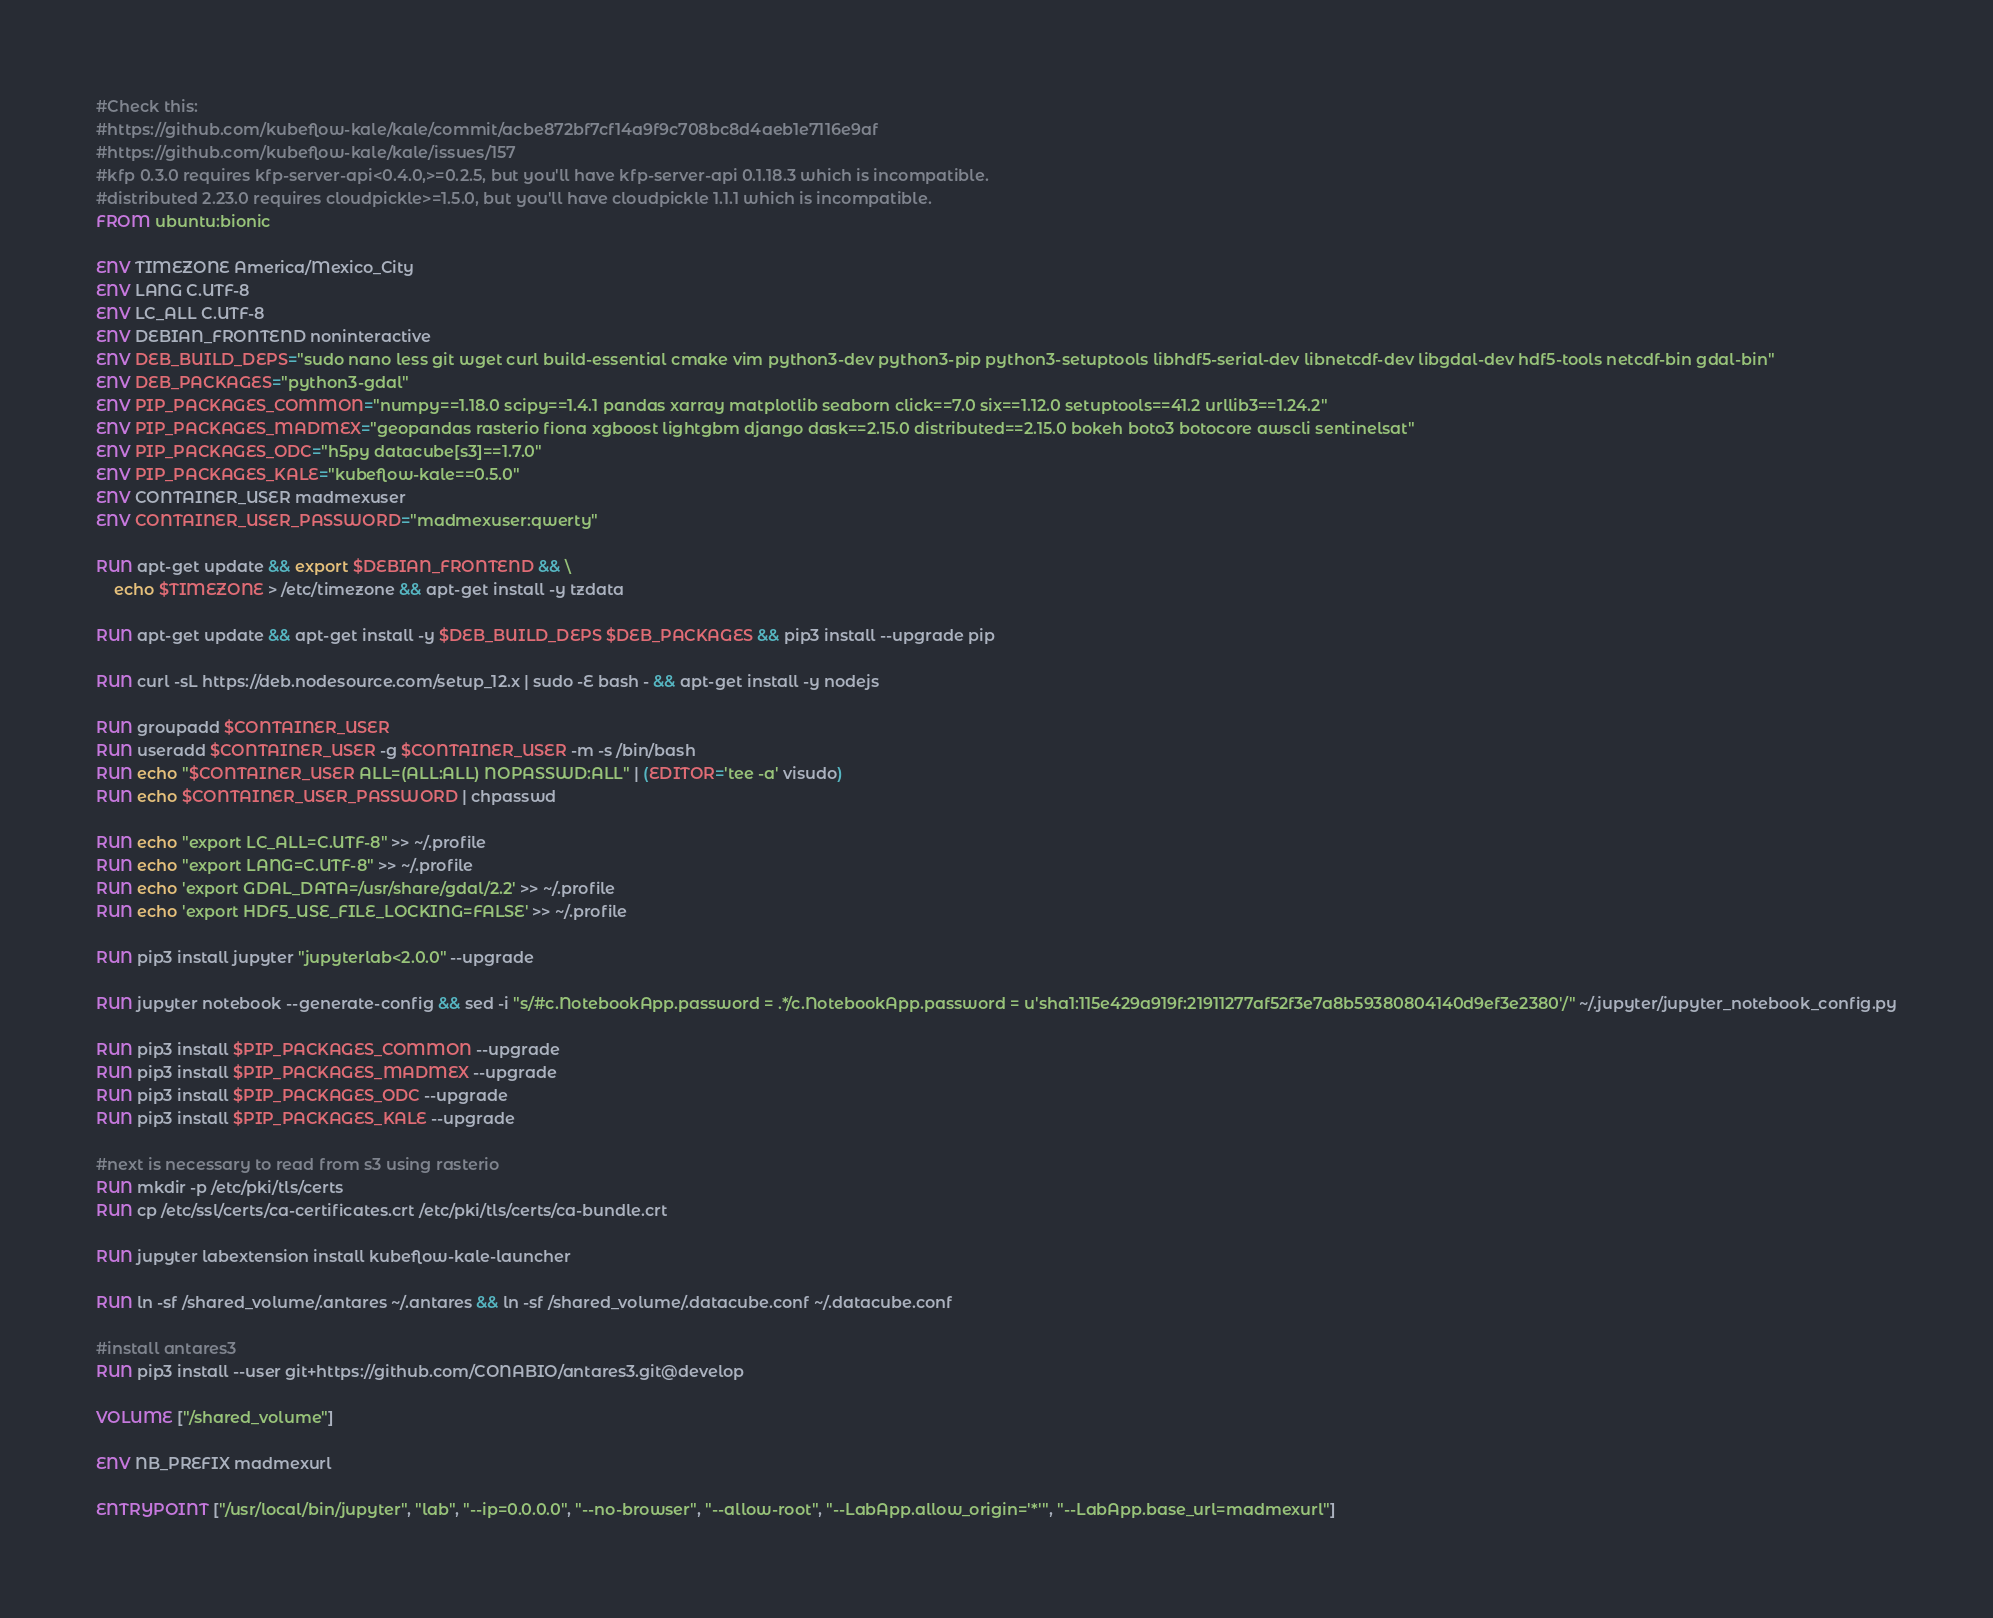Convert code to text. <code><loc_0><loc_0><loc_500><loc_500><_Dockerfile_>#Check this:
#https://github.com/kubeflow-kale/kale/commit/acbe872bf7cf14a9f9c708bc8d4aeb1e7116e9af
#https://github.com/kubeflow-kale/kale/issues/157
#kfp 0.3.0 requires kfp-server-api<0.4.0,>=0.2.5, but you'll have kfp-server-api 0.1.18.3 which is incompatible.
#distributed 2.23.0 requires cloudpickle>=1.5.0, but you'll have cloudpickle 1.1.1 which is incompatible.
FROM ubuntu:bionic

ENV TIMEZONE America/Mexico_City
ENV LANG C.UTF-8
ENV LC_ALL C.UTF-8
ENV DEBIAN_FRONTEND noninteractive 
ENV DEB_BUILD_DEPS="sudo nano less git wget curl build-essential cmake vim python3-dev python3-pip python3-setuptools libhdf5-serial-dev libnetcdf-dev libgdal-dev hdf5-tools netcdf-bin gdal-bin"
ENV DEB_PACKAGES="python3-gdal"
ENV PIP_PACKAGES_COMMON="numpy==1.18.0 scipy==1.4.1 pandas xarray matplotlib seaborn click==7.0 six==1.12.0 setuptools==41.2 urllib3==1.24.2"
ENV PIP_PACKAGES_MADMEX="geopandas rasterio fiona xgboost lightgbm django dask==2.15.0 distributed==2.15.0 bokeh boto3 botocore awscli sentinelsat"
ENV PIP_PACKAGES_ODC="h5py datacube[s3]==1.7.0"
ENV PIP_PACKAGES_KALE="kubeflow-kale==0.5.0"
ENV CONTAINER_USER madmexuser
ENV CONTAINER_USER_PASSWORD="madmexuser:qwerty"

RUN apt-get update && export $DEBIAN_FRONTEND && \
    echo $TIMEZONE > /etc/timezone && apt-get install -y tzdata

RUN apt-get update && apt-get install -y $DEB_BUILD_DEPS $DEB_PACKAGES && pip3 install --upgrade pip  

RUN curl -sL https://deb.nodesource.com/setup_12.x | sudo -E bash - && apt-get install -y nodejs

RUN groupadd $CONTAINER_USER
RUN useradd $CONTAINER_USER -g $CONTAINER_USER -m -s /bin/bash
RUN echo "$CONTAINER_USER ALL=(ALL:ALL) NOPASSWD:ALL" | (EDITOR='tee -a' visudo)
RUN echo $CONTAINER_USER_PASSWORD | chpasswd

RUN echo "export LC_ALL=C.UTF-8" >> ~/.profile
RUN echo "export LANG=C.UTF-8" >> ~/.profile
RUN echo 'export GDAL_DATA=/usr/share/gdal/2.2' >> ~/.profile
RUN echo 'export HDF5_USE_FILE_LOCKING=FALSE' >> ~/.profile

RUN pip3 install jupyter "jupyterlab<2.0.0" --upgrade

RUN jupyter notebook --generate-config && sed -i "s/#c.NotebookApp.password = .*/c.NotebookApp.password = u'sha1:115e429a919f:21911277af52f3e7a8b59380804140d9ef3e2380'/" ~/.jupyter/jupyter_notebook_config.py

RUN pip3 install $PIP_PACKAGES_COMMON --upgrade
RUN pip3 install $PIP_PACKAGES_MADMEX --upgrade
RUN pip3 install $PIP_PACKAGES_ODC --upgrade
RUN pip3 install $PIP_PACKAGES_KALE --upgrade

#next is necessary to read from s3 using rasterio
RUN mkdir -p /etc/pki/tls/certs
RUN cp /etc/ssl/certs/ca-certificates.crt /etc/pki/tls/certs/ca-bundle.crt

RUN jupyter labextension install kubeflow-kale-launcher

RUN ln -sf /shared_volume/.antares ~/.antares && ln -sf /shared_volume/.datacube.conf ~/.datacube.conf

#install antares3
RUN pip3 install --user git+https://github.com/CONABIO/antares3.git@develop

VOLUME ["/shared_volume"]

ENV NB_PREFIX madmexurl

ENTRYPOINT ["/usr/local/bin/jupyter", "lab", "--ip=0.0.0.0", "--no-browser", "--allow-root", "--LabApp.allow_origin='*'", "--LabApp.base_url=madmexurl"]
</code> 